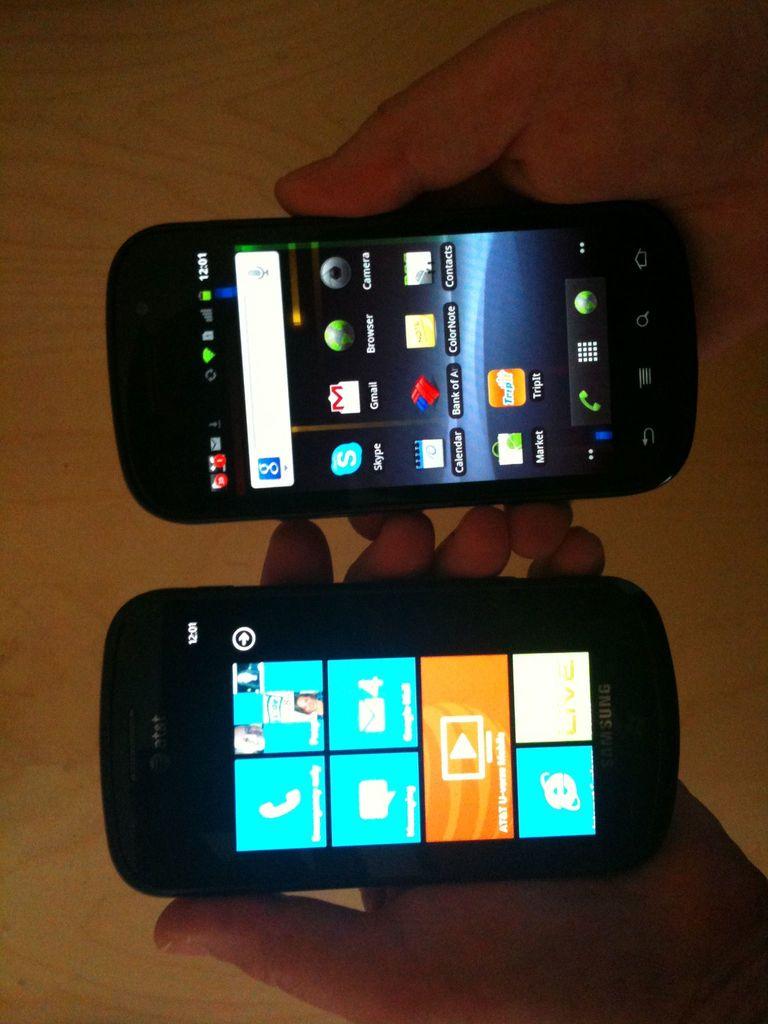Do either of the phones have u-verse?
Give a very brief answer. Yes. What is the name of the phone to the left?
Your response must be concise. Samsung. 